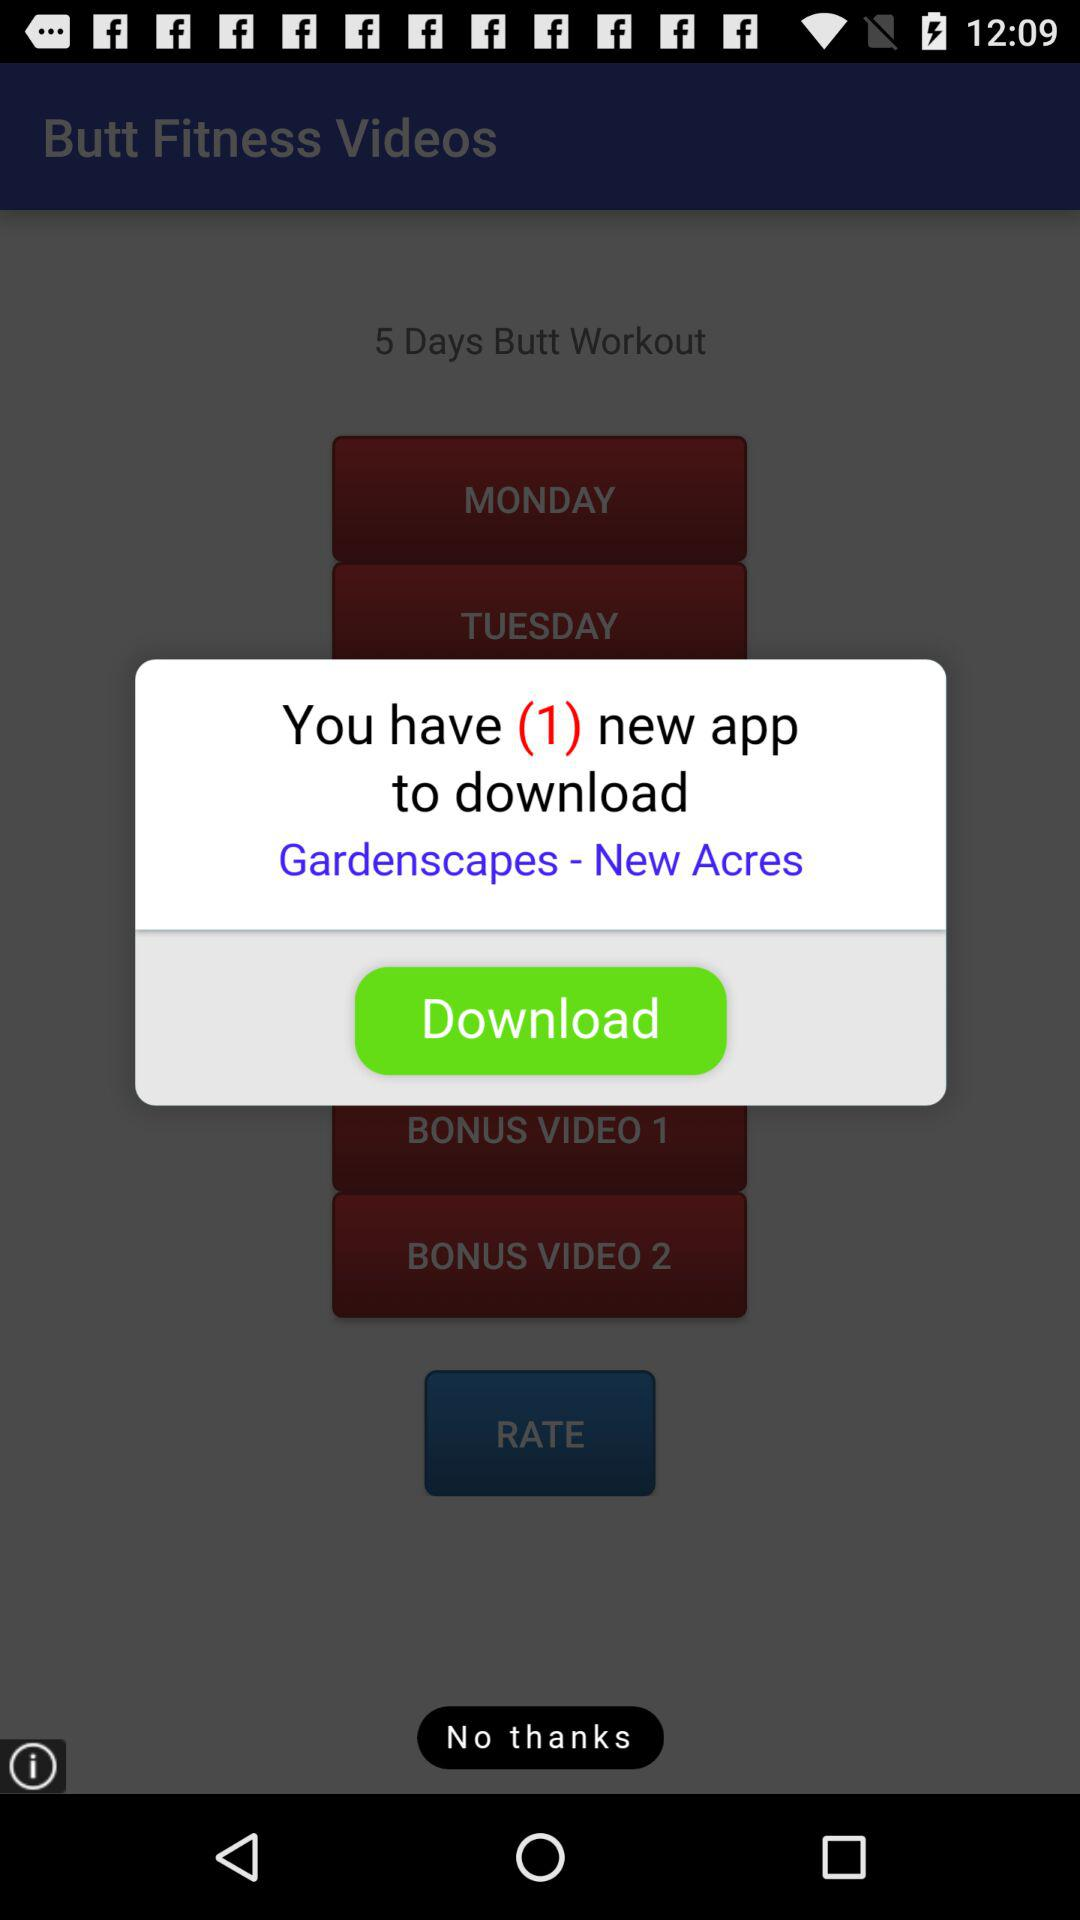What is the number of new applications to be downloaded? The number of new applications to be downloaded is 1. 